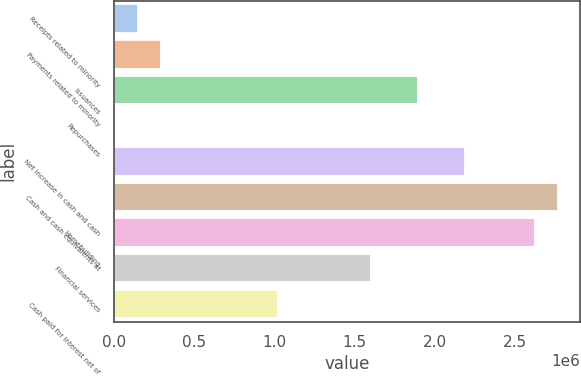<chart> <loc_0><loc_0><loc_500><loc_500><bar_chart><fcel>Receipts related to minority<fcel>Payments related to minority<fcel>Issuances<fcel>Repurchases<fcel>Net increase in cash and cash<fcel>Cash and cash equivalents at<fcel>Homebuilding<fcel>Financial services<fcel>Cash paid for interest net of<nl><fcel>147153<fcel>292740<fcel>1.8942e+06<fcel>1566<fcel>2.18537e+06<fcel>2.76772e+06<fcel>2.62214e+06<fcel>1.60303e+06<fcel>1.02068e+06<nl></chart> 